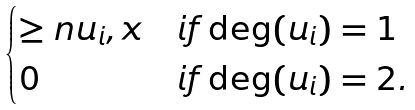Convert formula to latex. <formula><loc_0><loc_0><loc_500><loc_500>\begin{cases} \geq n { u _ { i } , x } & i f \deg ( u _ { i } ) = 1 \\ 0 & i f \deg ( u _ { i } ) = 2 . \end{cases}</formula> 